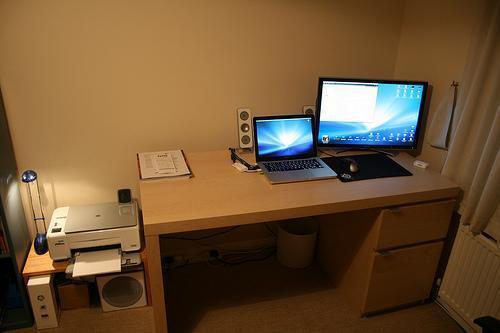How many printers are there?
Give a very brief answer. 1. How many computer screens are there?
Give a very brief answer. 2. How many drawers on the desk?
Give a very brief answer. 2. How many computers?
Give a very brief answer. 2. How many laptops?
Give a very brief answer. 1. How many drawers does the desk have?
Give a very brief answer. 2. 